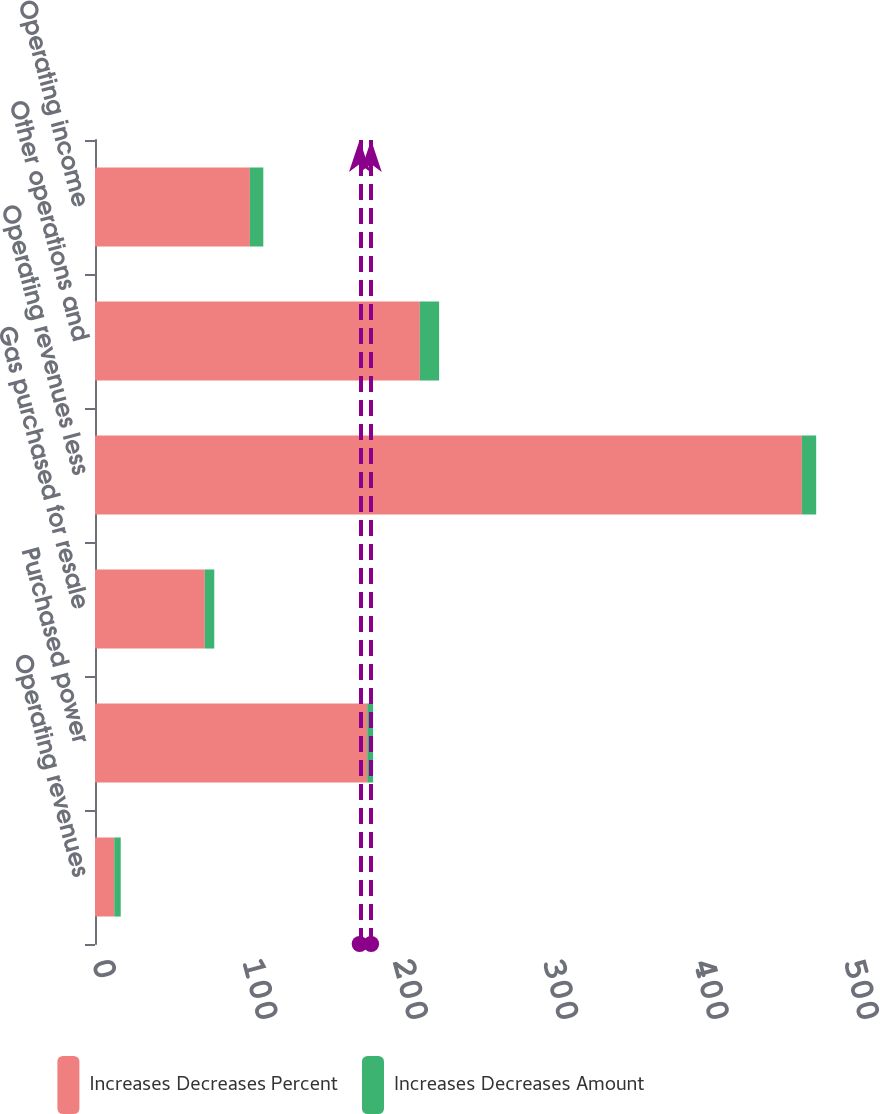<chart> <loc_0><loc_0><loc_500><loc_500><stacked_bar_chart><ecel><fcel>Operating revenues<fcel>Purchased power<fcel>Gas purchased for resale<fcel>Operating revenues less<fcel>Other operations and<fcel>Operating income<nl><fcel>Increases Decreases Percent<fcel>12.8<fcel>181<fcel>73<fcel>470<fcel>216<fcel>103<nl><fcel>Increases Decreases Amount<fcel>4.3<fcel>3.9<fcel>6.3<fcel>9.5<fcel>12.8<fcel>8.9<nl></chart> 